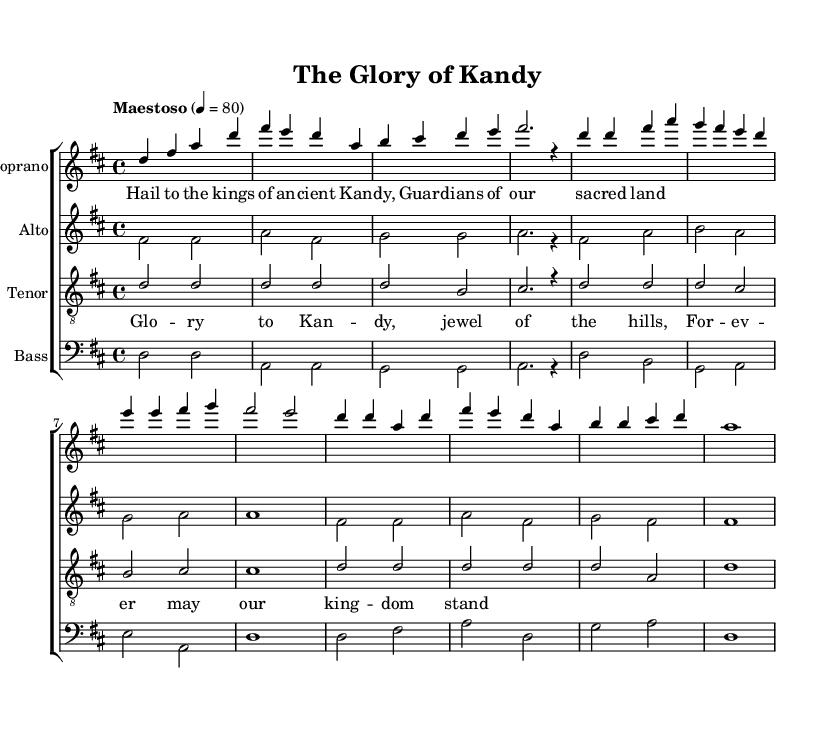What is the key signature of this music? The key signature is identified by looking at the beginning of the staff, which shows two sharps. The presence of sharps indicates that the piece is in a major key, and specifically, two sharps corresponds to D major.
Answer: D major What is the time signature of this music? The time signature is indicated at the beginning of the staff as 4/4, meaning there are four beats in each measure and the quarter note receives one beat.
Answer: 4/4 What is the tempo indication for the piece? The tempo marking at the beginning states "Maestoso," followed by a metronomic mark of 4 = 80, which indicates a moderately slow, dignified tempo.
Answer: Maestoso How many voices are specified in the score? By examining the layout of the score where each staff represents a different voice, we can count four distinct voices: Soprano, Alto, Tenor, and Bass.
Answer: Four In which section of the opera do the lyrics for the verse appear? The verse lyrics are placed under the Soprano line of the score, right after the global indications, and are noted as the introduction and verse part of the composition.
Answer: Soprano What is the lyrical theme presented in the chorus? The lyrics of the chorus express a patriotic theme, glorifying Kandyan heritage with phrases like "Glo -- ry to Kan -- dy" and emphasizes the desire for the kingdom to stand forever.
Answer: Glory to Kandy How is the Alto part primarily characterized in terms of musical role? In the score, the Alto part provides harmony and complements the Soprano line, with its notes supporting the main melodic line and contributing to the overall texture of the choral arrangement.
Answer: Harmony 